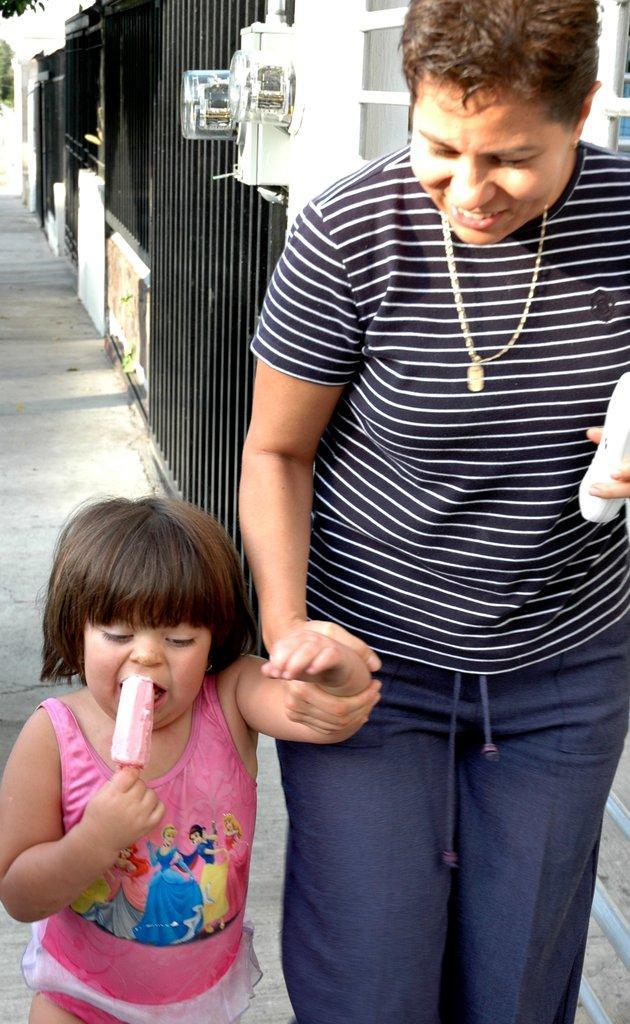Describe this image in one or two sentences. In this image there is a woman walking on the footpath by holding the kid. The kid is eating an ice cream. In the background there are grills and doors. 